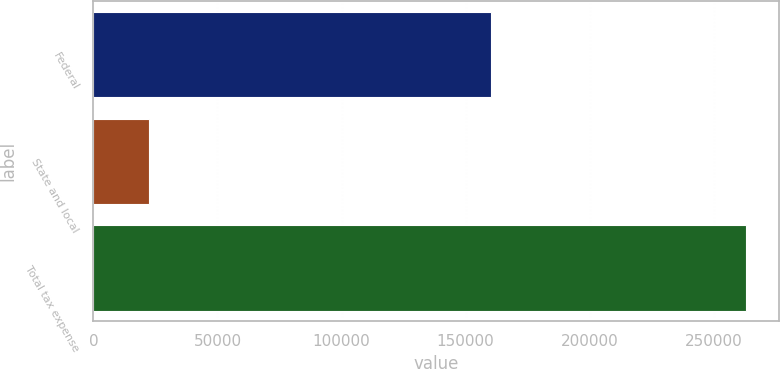Convert chart. <chart><loc_0><loc_0><loc_500><loc_500><bar_chart><fcel>Federal<fcel>State and local<fcel>Total tax expense<nl><fcel>160235<fcel>22306<fcel>262968<nl></chart> 